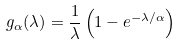Convert formula to latex. <formula><loc_0><loc_0><loc_500><loc_500>g _ { \alpha } ( \lambda ) = \frac { 1 } { \lambda } \left ( 1 - e ^ { - \lambda / \alpha } \right )</formula> 